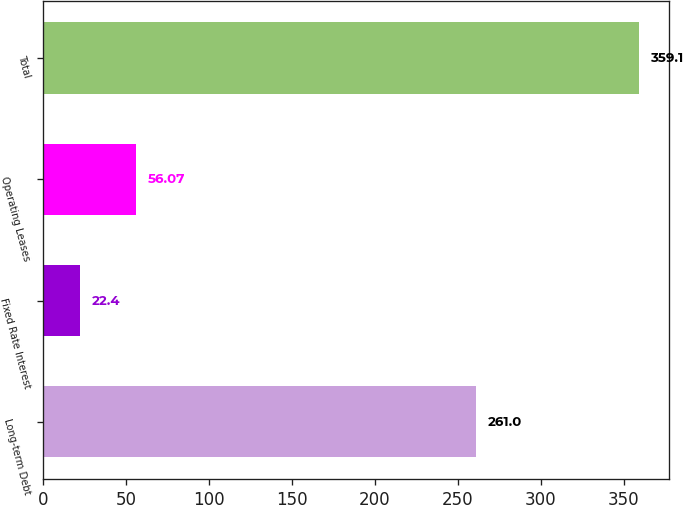Convert chart. <chart><loc_0><loc_0><loc_500><loc_500><bar_chart><fcel>Long-term Debt<fcel>Fixed Rate Interest<fcel>Operating Leases<fcel>Total<nl><fcel>261<fcel>22.4<fcel>56.07<fcel>359.1<nl></chart> 